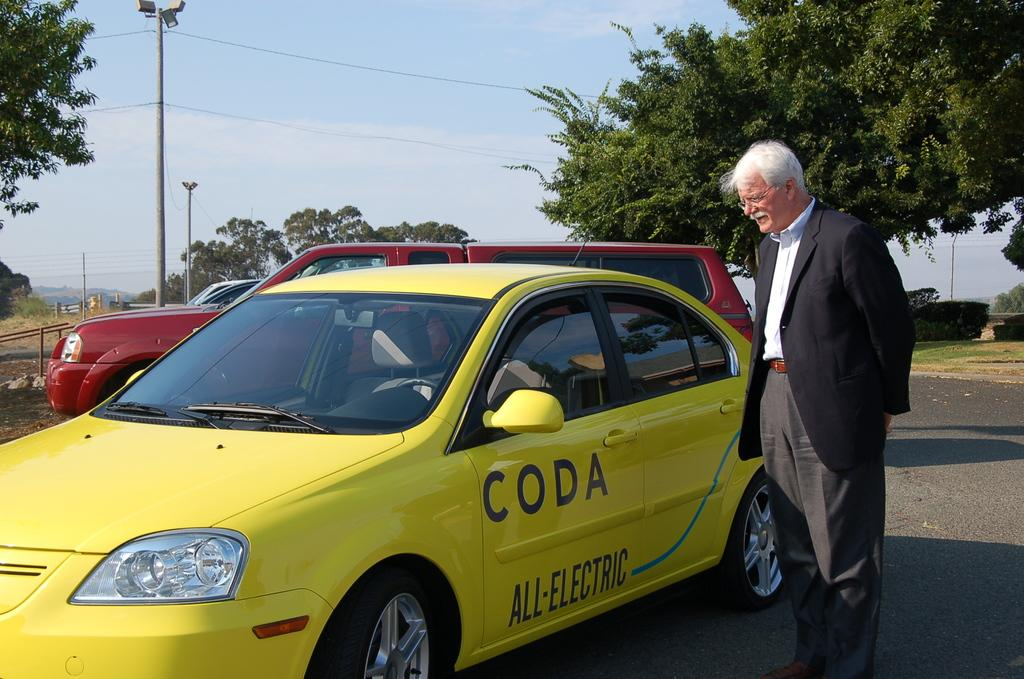<image>
Provide a brief description of the given image. A man stands outside the driver's side door of an electric car. 